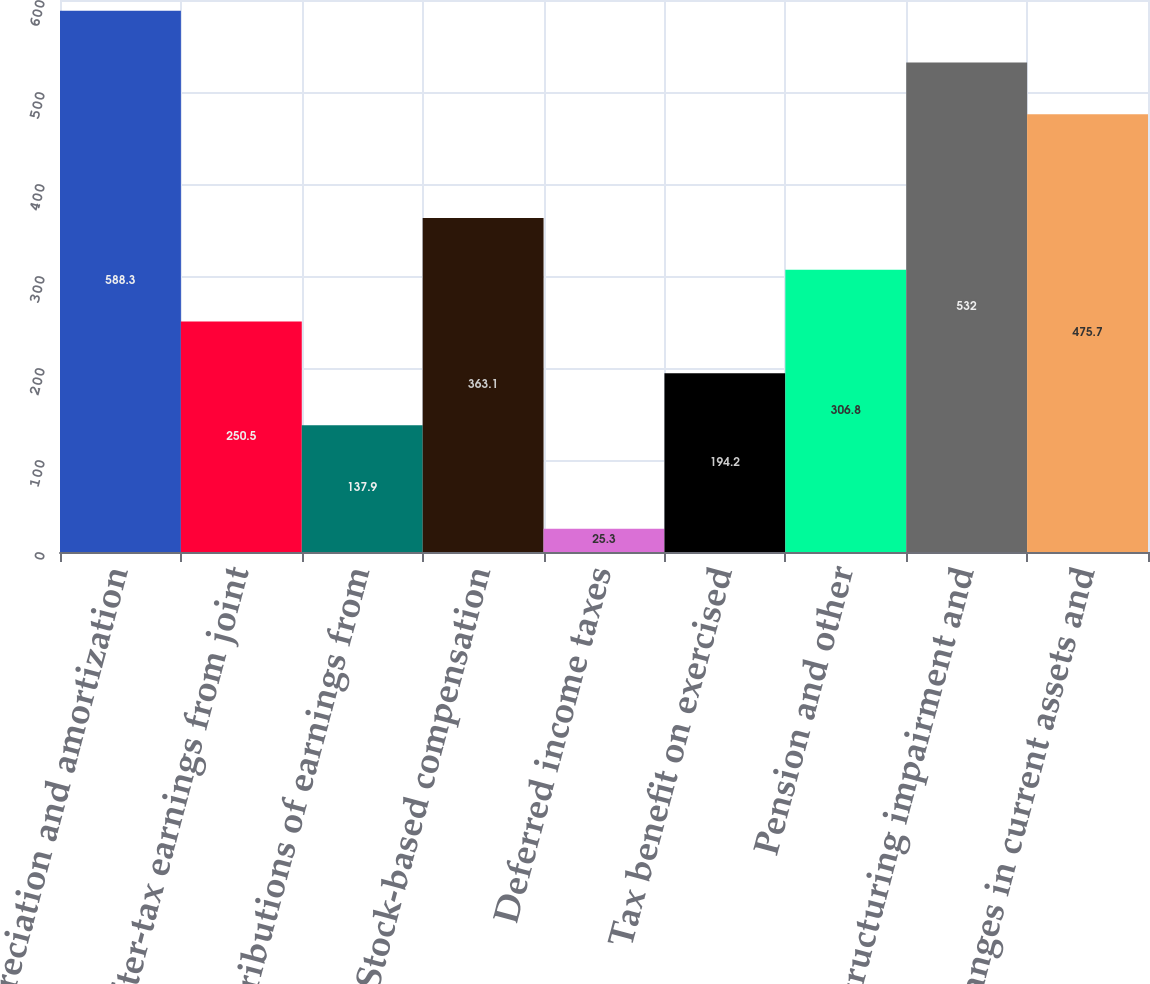Convert chart to OTSL. <chart><loc_0><loc_0><loc_500><loc_500><bar_chart><fcel>Depreciation and amortization<fcel>After-tax earnings from joint<fcel>Distributions of earnings from<fcel>Stock-based compensation<fcel>Deferred income taxes<fcel>Tax benefit on exercised<fcel>Pension and other<fcel>Restructuring impairment and<fcel>Changes in current assets and<nl><fcel>588.3<fcel>250.5<fcel>137.9<fcel>363.1<fcel>25.3<fcel>194.2<fcel>306.8<fcel>532<fcel>475.7<nl></chart> 